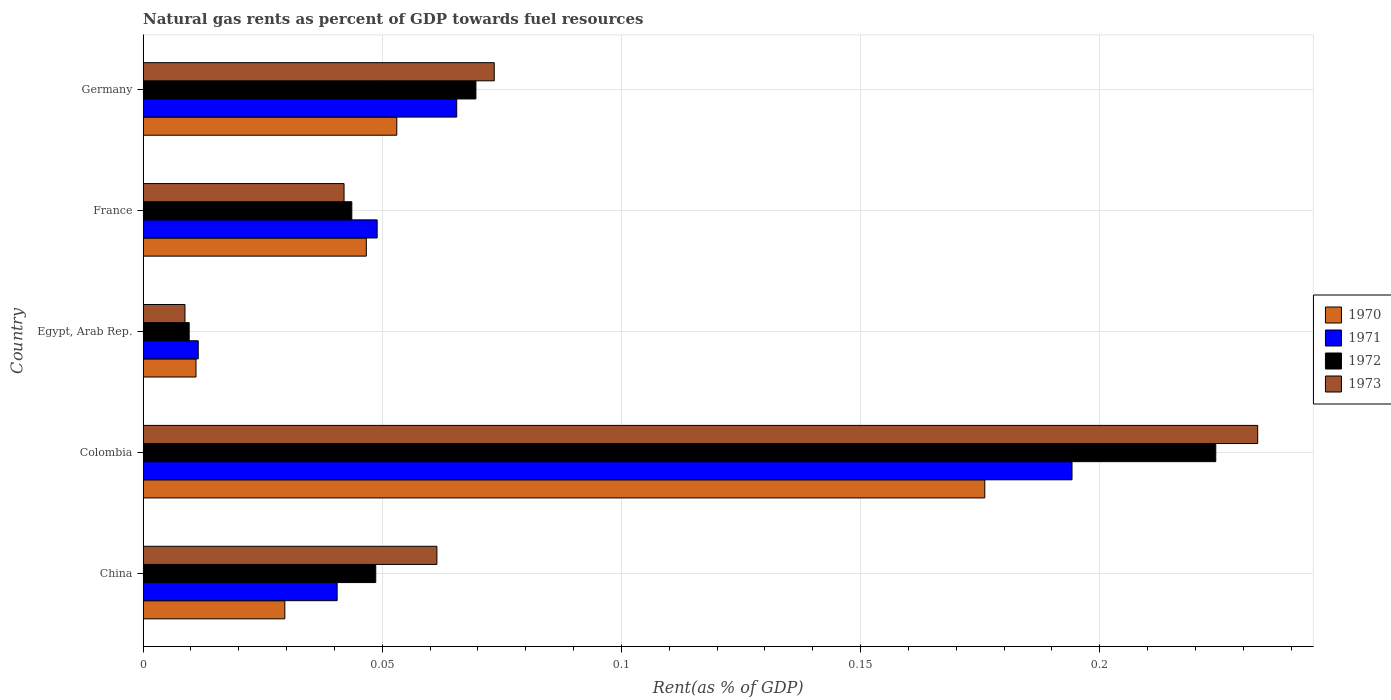How many groups of bars are there?
Your answer should be compact. 5. How many bars are there on the 3rd tick from the bottom?
Your response must be concise. 4. What is the label of the 3rd group of bars from the top?
Provide a succinct answer. Egypt, Arab Rep. What is the matural gas rent in 1971 in Germany?
Make the answer very short. 0.07. Across all countries, what is the maximum matural gas rent in 1970?
Your response must be concise. 0.18. Across all countries, what is the minimum matural gas rent in 1971?
Your answer should be very brief. 0.01. In which country was the matural gas rent in 1972 maximum?
Provide a succinct answer. Colombia. In which country was the matural gas rent in 1972 minimum?
Ensure brevity in your answer.  Egypt, Arab Rep. What is the total matural gas rent in 1973 in the graph?
Your response must be concise. 0.42. What is the difference between the matural gas rent in 1970 in China and that in Colombia?
Offer a very short reply. -0.15. What is the difference between the matural gas rent in 1973 in Egypt, Arab Rep. and the matural gas rent in 1972 in Colombia?
Give a very brief answer. -0.22. What is the average matural gas rent in 1970 per country?
Your response must be concise. 0.06. What is the difference between the matural gas rent in 1972 and matural gas rent in 1971 in Colombia?
Provide a succinct answer. 0.03. What is the ratio of the matural gas rent in 1973 in France to that in Germany?
Provide a short and direct response. 0.57. Is the difference between the matural gas rent in 1972 in Colombia and Egypt, Arab Rep. greater than the difference between the matural gas rent in 1971 in Colombia and Egypt, Arab Rep.?
Offer a very short reply. Yes. What is the difference between the highest and the second highest matural gas rent in 1972?
Provide a short and direct response. 0.15. What is the difference between the highest and the lowest matural gas rent in 1971?
Your answer should be very brief. 0.18. Is the sum of the matural gas rent in 1971 in Egypt, Arab Rep. and Germany greater than the maximum matural gas rent in 1970 across all countries?
Your response must be concise. No. What does the 3rd bar from the top in Colombia represents?
Offer a terse response. 1971. Does the graph contain any zero values?
Provide a short and direct response. No. Does the graph contain grids?
Offer a very short reply. Yes. How many legend labels are there?
Keep it short and to the point. 4. How are the legend labels stacked?
Offer a terse response. Vertical. What is the title of the graph?
Offer a terse response. Natural gas rents as percent of GDP towards fuel resources. What is the label or title of the X-axis?
Provide a succinct answer. Rent(as % of GDP). What is the Rent(as % of GDP) in 1970 in China?
Your answer should be compact. 0.03. What is the Rent(as % of GDP) of 1971 in China?
Make the answer very short. 0.04. What is the Rent(as % of GDP) of 1972 in China?
Your response must be concise. 0.05. What is the Rent(as % of GDP) of 1973 in China?
Keep it short and to the point. 0.06. What is the Rent(as % of GDP) of 1970 in Colombia?
Keep it short and to the point. 0.18. What is the Rent(as % of GDP) of 1971 in Colombia?
Make the answer very short. 0.19. What is the Rent(as % of GDP) in 1972 in Colombia?
Offer a very short reply. 0.22. What is the Rent(as % of GDP) of 1973 in Colombia?
Make the answer very short. 0.23. What is the Rent(as % of GDP) in 1970 in Egypt, Arab Rep.?
Your answer should be compact. 0.01. What is the Rent(as % of GDP) in 1971 in Egypt, Arab Rep.?
Offer a terse response. 0.01. What is the Rent(as % of GDP) of 1972 in Egypt, Arab Rep.?
Ensure brevity in your answer.  0.01. What is the Rent(as % of GDP) of 1973 in Egypt, Arab Rep.?
Your response must be concise. 0.01. What is the Rent(as % of GDP) of 1970 in France?
Ensure brevity in your answer.  0.05. What is the Rent(as % of GDP) of 1971 in France?
Ensure brevity in your answer.  0.05. What is the Rent(as % of GDP) in 1972 in France?
Offer a very short reply. 0.04. What is the Rent(as % of GDP) of 1973 in France?
Provide a succinct answer. 0.04. What is the Rent(as % of GDP) of 1970 in Germany?
Make the answer very short. 0.05. What is the Rent(as % of GDP) of 1971 in Germany?
Offer a very short reply. 0.07. What is the Rent(as % of GDP) of 1972 in Germany?
Keep it short and to the point. 0.07. What is the Rent(as % of GDP) of 1973 in Germany?
Offer a terse response. 0.07. Across all countries, what is the maximum Rent(as % of GDP) of 1970?
Keep it short and to the point. 0.18. Across all countries, what is the maximum Rent(as % of GDP) of 1971?
Offer a terse response. 0.19. Across all countries, what is the maximum Rent(as % of GDP) of 1972?
Give a very brief answer. 0.22. Across all countries, what is the maximum Rent(as % of GDP) in 1973?
Offer a terse response. 0.23. Across all countries, what is the minimum Rent(as % of GDP) in 1970?
Ensure brevity in your answer.  0.01. Across all countries, what is the minimum Rent(as % of GDP) in 1971?
Provide a succinct answer. 0.01. Across all countries, what is the minimum Rent(as % of GDP) of 1972?
Your answer should be compact. 0.01. Across all countries, what is the minimum Rent(as % of GDP) of 1973?
Your answer should be compact. 0.01. What is the total Rent(as % of GDP) in 1970 in the graph?
Ensure brevity in your answer.  0.32. What is the total Rent(as % of GDP) of 1971 in the graph?
Offer a terse response. 0.36. What is the total Rent(as % of GDP) in 1972 in the graph?
Provide a succinct answer. 0.4. What is the total Rent(as % of GDP) of 1973 in the graph?
Ensure brevity in your answer.  0.42. What is the difference between the Rent(as % of GDP) of 1970 in China and that in Colombia?
Your answer should be very brief. -0.15. What is the difference between the Rent(as % of GDP) in 1971 in China and that in Colombia?
Your response must be concise. -0.15. What is the difference between the Rent(as % of GDP) of 1972 in China and that in Colombia?
Your answer should be compact. -0.18. What is the difference between the Rent(as % of GDP) of 1973 in China and that in Colombia?
Your response must be concise. -0.17. What is the difference between the Rent(as % of GDP) of 1970 in China and that in Egypt, Arab Rep.?
Ensure brevity in your answer.  0.02. What is the difference between the Rent(as % of GDP) of 1971 in China and that in Egypt, Arab Rep.?
Keep it short and to the point. 0.03. What is the difference between the Rent(as % of GDP) of 1972 in China and that in Egypt, Arab Rep.?
Offer a terse response. 0.04. What is the difference between the Rent(as % of GDP) in 1973 in China and that in Egypt, Arab Rep.?
Ensure brevity in your answer.  0.05. What is the difference between the Rent(as % of GDP) in 1970 in China and that in France?
Your answer should be compact. -0.02. What is the difference between the Rent(as % of GDP) in 1971 in China and that in France?
Offer a very short reply. -0.01. What is the difference between the Rent(as % of GDP) of 1972 in China and that in France?
Offer a very short reply. 0.01. What is the difference between the Rent(as % of GDP) of 1973 in China and that in France?
Your answer should be compact. 0.02. What is the difference between the Rent(as % of GDP) in 1970 in China and that in Germany?
Offer a very short reply. -0.02. What is the difference between the Rent(as % of GDP) of 1971 in China and that in Germany?
Provide a short and direct response. -0.03. What is the difference between the Rent(as % of GDP) of 1972 in China and that in Germany?
Offer a very short reply. -0.02. What is the difference between the Rent(as % of GDP) of 1973 in China and that in Germany?
Provide a short and direct response. -0.01. What is the difference between the Rent(as % of GDP) of 1970 in Colombia and that in Egypt, Arab Rep.?
Your answer should be very brief. 0.16. What is the difference between the Rent(as % of GDP) in 1971 in Colombia and that in Egypt, Arab Rep.?
Provide a succinct answer. 0.18. What is the difference between the Rent(as % of GDP) of 1972 in Colombia and that in Egypt, Arab Rep.?
Provide a short and direct response. 0.21. What is the difference between the Rent(as % of GDP) of 1973 in Colombia and that in Egypt, Arab Rep.?
Provide a succinct answer. 0.22. What is the difference between the Rent(as % of GDP) of 1970 in Colombia and that in France?
Your answer should be very brief. 0.13. What is the difference between the Rent(as % of GDP) of 1971 in Colombia and that in France?
Provide a short and direct response. 0.15. What is the difference between the Rent(as % of GDP) in 1972 in Colombia and that in France?
Offer a terse response. 0.18. What is the difference between the Rent(as % of GDP) of 1973 in Colombia and that in France?
Offer a terse response. 0.19. What is the difference between the Rent(as % of GDP) of 1970 in Colombia and that in Germany?
Your response must be concise. 0.12. What is the difference between the Rent(as % of GDP) in 1971 in Colombia and that in Germany?
Provide a short and direct response. 0.13. What is the difference between the Rent(as % of GDP) in 1972 in Colombia and that in Germany?
Your answer should be compact. 0.15. What is the difference between the Rent(as % of GDP) of 1973 in Colombia and that in Germany?
Provide a short and direct response. 0.16. What is the difference between the Rent(as % of GDP) in 1970 in Egypt, Arab Rep. and that in France?
Keep it short and to the point. -0.04. What is the difference between the Rent(as % of GDP) in 1971 in Egypt, Arab Rep. and that in France?
Keep it short and to the point. -0.04. What is the difference between the Rent(as % of GDP) in 1972 in Egypt, Arab Rep. and that in France?
Make the answer very short. -0.03. What is the difference between the Rent(as % of GDP) of 1973 in Egypt, Arab Rep. and that in France?
Make the answer very short. -0.03. What is the difference between the Rent(as % of GDP) in 1970 in Egypt, Arab Rep. and that in Germany?
Offer a very short reply. -0.04. What is the difference between the Rent(as % of GDP) of 1971 in Egypt, Arab Rep. and that in Germany?
Provide a short and direct response. -0.05. What is the difference between the Rent(as % of GDP) of 1972 in Egypt, Arab Rep. and that in Germany?
Offer a terse response. -0.06. What is the difference between the Rent(as % of GDP) in 1973 in Egypt, Arab Rep. and that in Germany?
Ensure brevity in your answer.  -0.06. What is the difference between the Rent(as % of GDP) in 1970 in France and that in Germany?
Your answer should be very brief. -0.01. What is the difference between the Rent(as % of GDP) of 1971 in France and that in Germany?
Provide a succinct answer. -0.02. What is the difference between the Rent(as % of GDP) of 1972 in France and that in Germany?
Your response must be concise. -0.03. What is the difference between the Rent(as % of GDP) in 1973 in France and that in Germany?
Provide a succinct answer. -0.03. What is the difference between the Rent(as % of GDP) of 1970 in China and the Rent(as % of GDP) of 1971 in Colombia?
Give a very brief answer. -0.16. What is the difference between the Rent(as % of GDP) of 1970 in China and the Rent(as % of GDP) of 1972 in Colombia?
Offer a terse response. -0.19. What is the difference between the Rent(as % of GDP) in 1970 in China and the Rent(as % of GDP) in 1973 in Colombia?
Give a very brief answer. -0.2. What is the difference between the Rent(as % of GDP) in 1971 in China and the Rent(as % of GDP) in 1972 in Colombia?
Your response must be concise. -0.18. What is the difference between the Rent(as % of GDP) in 1971 in China and the Rent(as % of GDP) in 1973 in Colombia?
Offer a terse response. -0.19. What is the difference between the Rent(as % of GDP) in 1972 in China and the Rent(as % of GDP) in 1973 in Colombia?
Offer a terse response. -0.18. What is the difference between the Rent(as % of GDP) in 1970 in China and the Rent(as % of GDP) in 1971 in Egypt, Arab Rep.?
Provide a succinct answer. 0.02. What is the difference between the Rent(as % of GDP) in 1970 in China and the Rent(as % of GDP) in 1973 in Egypt, Arab Rep.?
Offer a very short reply. 0.02. What is the difference between the Rent(as % of GDP) in 1971 in China and the Rent(as % of GDP) in 1972 in Egypt, Arab Rep.?
Offer a very short reply. 0.03. What is the difference between the Rent(as % of GDP) in 1971 in China and the Rent(as % of GDP) in 1973 in Egypt, Arab Rep.?
Offer a very short reply. 0.03. What is the difference between the Rent(as % of GDP) in 1972 in China and the Rent(as % of GDP) in 1973 in Egypt, Arab Rep.?
Give a very brief answer. 0.04. What is the difference between the Rent(as % of GDP) of 1970 in China and the Rent(as % of GDP) of 1971 in France?
Offer a terse response. -0.02. What is the difference between the Rent(as % of GDP) in 1970 in China and the Rent(as % of GDP) in 1972 in France?
Your response must be concise. -0.01. What is the difference between the Rent(as % of GDP) of 1970 in China and the Rent(as % of GDP) of 1973 in France?
Give a very brief answer. -0.01. What is the difference between the Rent(as % of GDP) of 1971 in China and the Rent(as % of GDP) of 1972 in France?
Provide a short and direct response. -0. What is the difference between the Rent(as % of GDP) of 1971 in China and the Rent(as % of GDP) of 1973 in France?
Give a very brief answer. -0. What is the difference between the Rent(as % of GDP) of 1972 in China and the Rent(as % of GDP) of 1973 in France?
Your answer should be compact. 0.01. What is the difference between the Rent(as % of GDP) of 1970 in China and the Rent(as % of GDP) of 1971 in Germany?
Provide a short and direct response. -0.04. What is the difference between the Rent(as % of GDP) of 1970 in China and the Rent(as % of GDP) of 1972 in Germany?
Provide a succinct answer. -0.04. What is the difference between the Rent(as % of GDP) of 1970 in China and the Rent(as % of GDP) of 1973 in Germany?
Provide a succinct answer. -0.04. What is the difference between the Rent(as % of GDP) of 1971 in China and the Rent(as % of GDP) of 1972 in Germany?
Your response must be concise. -0.03. What is the difference between the Rent(as % of GDP) in 1971 in China and the Rent(as % of GDP) in 1973 in Germany?
Offer a terse response. -0.03. What is the difference between the Rent(as % of GDP) of 1972 in China and the Rent(as % of GDP) of 1973 in Germany?
Provide a short and direct response. -0.02. What is the difference between the Rent(as % of GDP) of 1970 in Colombia and the Rent(as % of GDP) of 1971 in Egypt, Arab Rep.?
Provide a short and direct response. 0.16. What is the difference between the Rent(as % of GDP) in 1970 in Colombia and the Rent(as % of GDP) in 1972 in Egypt, Arab Rep.?
Provide a short and direct response. 0.17. What is the difference between the Rent(as % of GDP) in 1970 in Colombia and the Rent(as % of GDP) in 1973 in Egypt, Arab Rep.?
Ensure brevity in your answer.  0.17. What is the difference between the Rent(as % of GDP) of 1971 in Colombia and the Rent(as % of GDP) of 1972 in Egypt, Arab Rep.?
Make the answer very short. 0.18. What is the difference between the Rent(as % of GDP) in 1971 in Colombia and the Rent(as % of GDP) in 1973 in Egypt, Arab Rep.?
Your answer should be compact. 0.19. What is the difference between the Rent(as % of GDP) of 1972 in Colombia and the Rent(as % of GDP) of 1973 in Egypt, Arab Rep.?
Give a very brief answer. 0.22. What is the difference between the Rent(as % of GDP) in 1970 in Colombia and the Rent(as % of GDP) in 1971 in France?
Provide a short and direct response. 0.13. What is the difference between the Rent(as % of GDP) of 1970 in Colombia and the Rent(as % of GDP) of 1972 in France?
Ensure brevity in your answer.  0.13. What is the difference between the Rent(as % of GDP) of 1970 in Colombia and the Rent(as % of GDP) of 1973 in France?
Provide a succinct answer. 0.13. What is the difference between the Rent(as % of GDP) in 1971 in Colombia and the Rent(as % of GDP) in 1972 in France?
Ensure brevity in your answer.  0.15. What is the difference between the Rent(as % of GDP) of 1971 in Colombia and the Rent(as % of GDP) of 1973 in France?
Provide a short and direct response. 0.15. What is the difference between the Rent(as % of GDP) of 1972 in Colombia and the Rent(as % of GDP) of 1973 in France?
Your answer should be compact. 0.18. What is the difference between the Rent(as % of GDP) in 1970 in Colombia and the Rent(as % of GDP) in 1971 in Germany?
Your answer should be compact. 0.11. What is the difference between the Rent(as % of GDP) of 1970 in Colombia and the Rent(as % of GDP) of 1972 in Germany?
Keep it short and to the point. 0.11. What is the difference between the Rent(as % of GDP) of 1970 in Colombia and the Rent(as % of GDP) of 1973 in Germany?
Your answer should be very brief. 0.1. What is the difference between the Rent(as % of GDP) of 1971 in Colombia and the Rent(as % of GDP) of 1972 in Germany?
Offer a terse response. 0.12. What is the difference between the Rent(as % of GDP) of 1971 in Colombia and the Rent(as % of GDP) of 1973 in Germany?
Your response must be concise. 0.12. What is the difference between the Rent(as % of GDP) of 1972 in Colombia and the Rent(as % of GDP) of 1973 in Germany?
Make the answer very short. 0.15. What is the difference between the Rent(as % of GDP) in 1970 in Egypt, Arab Rep. and the Rent(as % of GDP) in 1971 in France?
Provide a short and direct response. -0.04. What is the difference between the Rent(as % of GDP) in 1970 in Egypt, Arab Rep. and the Rent(as % of GDP) in 1972 in France?
Offer a terse response. -0.03. What is the difference between the Rent(as % of GDP) in 1970 in Egypt, Arab Rep. and the Rent(as % of GDP) in 1973 in France?
Provide a short and direct response. -0.03. What is the difference between the Rent(as % of GDP) of 1971 in Egypt, Arab Rep. and the Rent(as % of GDP) of 1972 in France?
Make the answer very short. -0.03. What is the difference between the Rent(as % of GDP) in 1971 in Egypt, Arab Rep. and the Rent(as % of GDP) in 1973 in France?
Your response must be concise. -0.03. What is the difference between the Rent(as % of GDP) in 1972 in Egypt, Arab Rep. and the Rent(as % of GDP) in 1973 in France?
Give a very brief answer. -0.03. What is the difference between the Rent(as % of GDP) in 1970 in Egypt, Arab Rep. and the Rent(as % of GDP) in 1971 in Germany?
Keep it short and to the point. -0.05. What is the difference between the Rent(as % of GDP) in 1970 in Egypt, Arab Rep. and the Rent(as % of GDP) in 1972 in Germany?
Your answer should be very brief. -0.06. What is the difference between the Rent(as % of GDP) in 1970 in Egypt, Arab Rep. and the Rent(as % of GDP) in 1973 in Germany?
Your response must be concise. -0.06. What is the difference between the Rent(as % of GDP) in 1971 in Egypt, Arab Rep. and the Rent(as % of GDP) in 1972 in Germany?
Your answer should be very brief. -0.06. What is the difference between the Rent(as % of GDP) of 1971 in Egypt, Arab Rep. and the Rent(as % of GDP) of 1973 in Germany?
Provide a succinct answer. -0.06. What is the difference between the Rent(as % of GDP) in 1972 in Egypt, Arab Rep. and the Rent(as % of GDP) in 1973 in Germany?
Offer a very short reply. -0.06. What is the difference between the Rent(as % of GDP) of 1970 in France and the Rent(as % of GDP) of 1971 in Germany?
Give a very brief answer. -0.02. What is the difference between the Rent(as % of GDP) of 1970 in France and the Rent(as % of GDP) of 1972 in Germany?
Give a very brief answer. -0.02. What is the difference between the Rent(as % of GDP) in 1970 in France and the Rent(as % of GDP) in 1973 in Germany?
Provide a short and direct response. -0.03. What is the difference between the Rent(as % of GDP) in 1971 in France and the Rent(as % of GDP) in 1972 in Germany?
Your answer should be compact. -0.02. What is the difference between the Rent(as % of GDP) in 1971 in France and the Rent(as % of GDP) in 1973 in Germany?
Offer a very short reply. -0.02. What is the difference between the Rent(as % of GDP) in 1972 in France and the Rent(as % of GDP) in 1973 in Germany?
Provide a short and direct response. -0.03. What is the average Rent(as % of GDP) in 1970 per country?
Your answer should be very brief. 0.06. What is the average Rent(as % of GDP) in 1971 per country?
Give a very brief answer. 0.07. What is the average Rent(as % of GDP) in 1972 per country?
Offer a very short reply. 0.08. What is the average Rent(as % of GDP) in 1973 per country?
Offer a very short reply. 0.08. What is the difference between the Rent(as % of GDP) in 1970 and Rent(as % of GDP) in 1971 in China?
Give a very brief answer. -0.01. What is the difference between the Rent(as % of GDP) of 1970 and Rent(as % of GDP) of 1972 in China?
Make the answer very short. -0.02. What is the difference between the Rent(as % of GDP) of 1970 and Rent(as % of GDP) of 1973 in China?
Your answer should be very brief. -0.03. What is the difference between the Rent(as % of GDP) in 1971 and Rent(as % of GDP) in 1972 in China?
Ensure brevity in your answer.  -0.01. What is the difference between the Rent(as % of GDP) of 1971 and Rent(as % of GDP) of 1973 in China?
Offer a very short reply. -0.02. What is the difference between the Rent(as % of GDP) of 1972 and Rent(as % of GDP) of 1973 in China?
Offer a terse response. -0.01. What is the difference between the Rent(as % of GDP) in 1970 and Rent(as % of GDP) in 1971 in Colombia?
Give a very brief answer. -0.02. What is the difference between the Rent(as % of GDP) of 1970 and Rent(as % of GDP) of 1972 in Colombia?
Your answer should be compact. -0.05. What is the difference between the Rent(as % of GDP) in 1970 and Rent(as % of GDP) in 1973 in Colombia?
Your answer should be very brief. -0.06. What is the difference between the Rent(as % of GDP) of 1971 and Rent(as % of GDP) of 1972 in Colombia?
Your answer should be compact. -0.03. What is the difference between the Rent(as % of GDP) of 1971 and Rent(as % of GDP) of 1973 in Colombia?
Your answer should be compact. -0.04. What is the difference between the Rent(as % of GDP) in 1972 and Rent(as % of GDP) in 1973 in Colombia?
Your answer should be compact. -0.01. What is the difference between the Rent(as % of GDP) in 1970 and Rent(as % of GDP) in 1971 in Egypt, Arab Rep.?
Offer a very short reply. -0. What is the difference between the Rent(as % of GDP) of 1970 and Rent(as % of GDP) of 1972 in Egypt, Arab Rep.?
Your answer should be very brief. 0. What is the difference between the Rent(as % of GDP) in 1970 and Rent(as % of GDP) in 1973 in Egypt, Arab Rep.?
Provide a short and direct response. 0. What is the difference between the Rent(as % of GDP) of 1971 and Rent(as % of GDP) of 1972 in Egypt, Arab Rep.?
Your answer should be compact. 0. What is the difference between the Rent(as % of GDP) of 1971 and Rent(as % of GDP) of 1973 in Egypt, Arab Rep.?
Offer a terse response. 0. What is the difference between the Rent(as % of GDP) in 1972 and Rent(as % of GDP) in 1973 in Egypt, Arab Rep.?
Provide a succinct answer. 0. What is the difference between the Rent(as % of GDP) in 1970 and Rent(as % of GDP) in 1971 in France?
Keep it short and to the point. -0. What is the difference between the Rent(as % of GDP) in 1970 and Rent(as % of GDP) in 1972 in France?
Provide a succinct answer. 0. What is the difference between the Rent(as % of GDP) of 1970 and Rent(as % of GDP) of 1973 in France?
Your response must be concise. 0. What is the difference between the Rent(as % of GDP) of 1971 and Rent(as % of GDP) of 1972 in France?
Keep it short and to the point. 0.01. What is the difference between the Rent(as % of GDP) in 1971 and Rent(as % of GDP) in 1973 in France?
Offer a very short reply. 0.01. What is the difference between the Rent(as % of GDP) of 1972 and Rent(as % of GDP) of 1973 in France?
Provide a short and direct response. 0. What is the difference between the Rent(as % of GDP) in 1970 and Rent(as % of GDP) in 1971 in Germany?
Provide a short and direct response. -0.01. What is the difference between the Rent(as % of GDP) of 1970 and Rent(as % of GDP) of 1972 in Germany?
Give a very brief answer. -0.02. What is the difference between the Rent(as % of GDP) in 1970 and Rent(as % of GDP) in 1973 in Germany?
Provide a short and direct response. -0.02. What is the difference between the Rent(as % of GDP) in 1971 and Rent(as % of GDP) in 1972 in Germany?
Your answer should be very brief. -0. What is the difference between the Rent(as % of GDP) of 1971 and Rent(as % of GDP) of 1973 in Germany?
Ensure brevity in your answer.  -0.01. What is the difference between the Rent(as % of GDP) in 1972 and Rent(as % of GDP) in 1973 in Germany?
Your answer should be compact. -0. What is the ratio of the Rent(as % of GDP) in 1970 in China to that in Colombia?
Offer a terse response. 0.17. What is the ratio of the Rent(as % of GDP) of 1971 in China to that in Colombia?
Give a very brief answer. 0.21. What is the ratio of the Rent(as % of GDP) in 1972 in China to that in Colombia?
Keep it short and to the point. 0.22. What is the ratio of the Rent(as % of GDP) in 1973 in China to that in Colombia?
Your answer should be compact. 0.26. What is the ratio of the Rent(as % of GDP) in 1970 in China to that in Egypt, Arab Rep.?
Keep it short and to the point. 2.68. What is the ratio of the Rent(as % of GDP) of 1971 in China to that in Egypt, Arab Rep.?
Offer a terse response. 3.52. What is the ratio of the Rent(as % of GDP) of 1972 in China to that in Egypt, Arab Rep.?
Your answer should be very brief. 5.04. What is the ratio of the Rent(as % of GDP) in 1973 in China to that in Egypt, Arab Rep.?
Give a very brief answer. 7.01. What is the ratio of the Rent(as % of GDP) in 1970 in China to that in France?
Offer a terse response. 0.64. What is the ratio of the Rent(as % of GDP) of 1971 in China to that in France?
Your answer should be very brief. 0.83. What is the ratio of the Rent(as % of GDP) in 1972 in China to that in France?
Give a very brief answer. 1.11. What is the ratio of the Rent(as % of GDP) of 1973 in China to that in France?
Provide a succinct answer. 1.46. What is the ratio of the Rent(as % of GDP) of 1970 in China to that in Germany?
Ensure brevity in your answer.  0.56. What is the ratio of the Rent(as % of GDP) in 1971 in China to that in Germany?
Keep it short and to the point. 0.62. What is the ratio of the Rent(as % of GDP) in 1972 in China to that in Germany?
Make the answer very short. 0.7. What is the ratio of the Rent(as % of GDP) in 1973 in China to that in Germany?
Give a very brief answer. 0.84. What is the ratio of the Rent(as % of GDP) of 1970 in Colombia to that in Egypt, Arab Rep.?
Make the answer very short. 15.9. What is the ratio of the Rent(as % of GDP) in 1971 in Colombia to that in Egypt, Arab Rep.?
Offer a terse response. 16.84. What is the ratio of the Rent(as % of GDP) of 1972 in Colombia to that in Egypt, Arab Rep.?
Provide a succinct answer. 23.25. What is the ratio of the Rent(as % of GDP) of 1973 in Colombia to that in Egypt, Arab Rep.?
Provide a succinct answer. 26.6. What is the ratio of the Rent(as % of GDP) of 1970 in Colombia to that in France?
Provide a succinct answer. 3.77. What is the ratio of the Rent(as % of GDP) of 1971 in Colombia to that in France?
Give a very brief answer. 3.97. What is the ratio of the Rent(as % of GDP) of 1972 in Colombia to that in France?
Offer a very short reply. 5.14. What is the ratio of the Rent(as % of GDP) of 1973 in Colombia to that in France?
Keep it short and to the point. 5.55. What is the ratio of the Rent(as % of GDP) of 1970 in Colombia to that in Germany?
Make the answer very short. 3.32. What is the ratio of the Rent(as % of GDP) in 1971 in Colombia to that in Germany?
Your answer should be very brief. 2.96. What is the ratio of the Rent(as % of GDP) in 1972 in Colombia to that in Germany?
Offer a terse response. 3.22. What is the ratio of the Rent(as % of GDP) in 1973 in Colombia to that in Germany?
Your answer should be compact. 3.17. What is the ratio of the Rent(as % of GDP) in 1970 in Egypt, Arab Rep. to that in France?
Keep it short and to the point. 0.24. What is the ratio of the Rent(as % of GDP) in 1971 in Egypt, Arab Rep. to that in France?
Offer a terse response. 0.24. What is the ratio of the Rent(as % of GDP) in 1972 in Egypt, Arab Rep. to that in France?
Provide a short and direct response. 0.22. What is the ratio of the Rent(as % of GDP) of 1973 in Egypt, Arab Rep. to that in France?
Your answer should be very brief. 0.21. What is the ratio of the Rent(as % of GDP) in 1970 in Egypt, Arab Rep. to that in Germany?
Keep it short and to the point. 0.21. What is the ratio of the Rent(as % of GDP) of 1971 in Egypt, Arab Rep. to that in Germany?
Offer a very short reply. 0.18. What is the ratio of the Rent(as % of GDP) in 1972 in Egypt, Arab Rep. to that in Germany?
Ensure brevity in your answer.  0.14. What is the ratio of the Rent(as % of GDP) in 1973 in Egypt, Arab Rep. to that in Germany?
Offer a terse response. 0.12. What is the ratio of the Rent(as % of GDP) of 1970 in France to that in Germany?
Make the answer very short. 0.88. What is the ratio of the Rent(as % of GDP) of 1971 in France to that in Germany?
Keep it short and to the point. 0.75. What is the ratio of the Rent(as % of GDP) in 1972 in France to that in Germany?
Offer a terse response. 0.63. What is the ratio of the Rent(as % of GDP) in 1973 in France to that in Germany?
Your answer should be compact. 0.57. What is the difference between the highest and the second highest Rent(as % of GDP) in 1970?
Make the answer very short. 0.12. What is the difference between the highest and the second highest Rent(as % of GDP) in 1971?
Your answer should be compact. 0.13. What is the difference between the highest and the second highest Rent(as % of GDP) in 1972?
Ensure brevity in your answer.  0.15. What is the difference between the highest and the second highest Rent(as % of GDP) of 1973?
Make the answer very short. 0.16. What is the difference between the highest and the lowest Rent(as % of GDP) in 1970?
Ensure brevity in your answer.  0.16. What is the difference between the highest and the lowest Rent(as % of GDP) in 1971?
Provide a short and direct response. 0.18. What is the difference between the highest and the lowest Rent(as % of GDP) in 1972?
Provide a short and direct response. 0.21. What is the difference between the highest and the lowest Rent(as % of GDP) in 1973?
Provide a succinct answer. 0.22. 